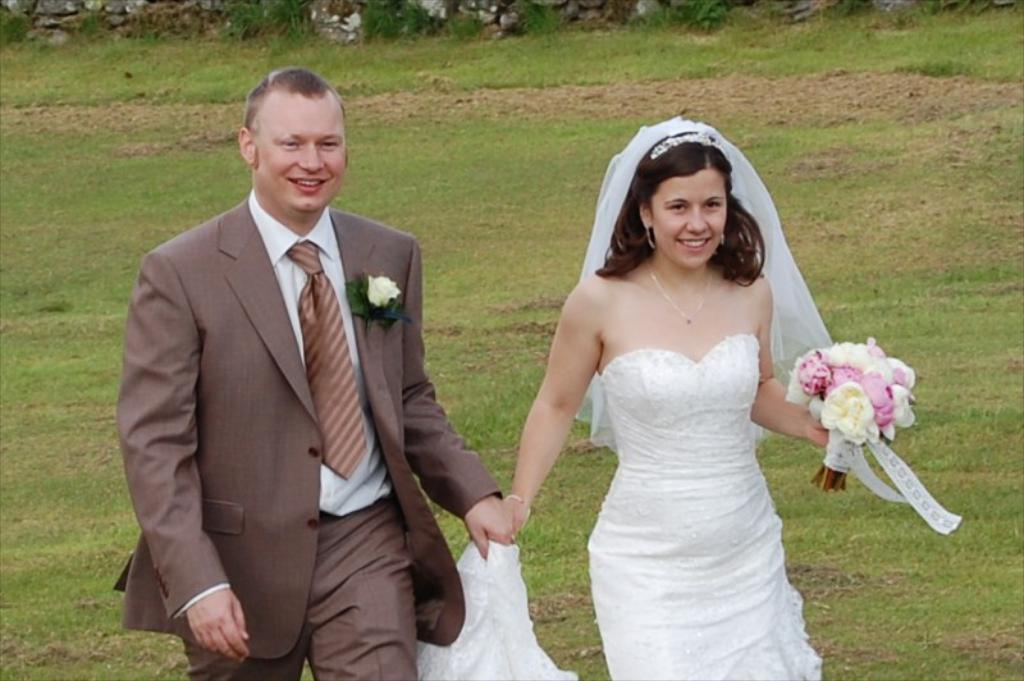What are the two people in the image doing? There is a couple walking in the image. What type of vegetation can be seen in the image? There are flowers and grass in the image. How many weeks has the couple's son been alive in the image? There is no mention of a son in the image, so it is not possible to determine how many weeks he might have been alive. 